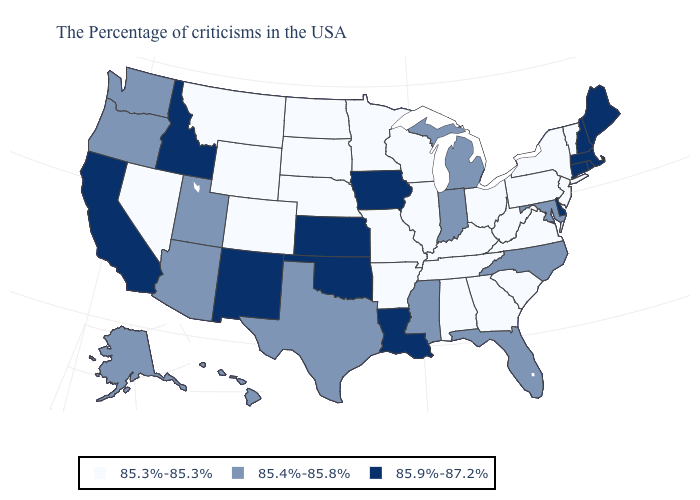What is the value of Montana?
Write a very short answer. 85.3%-85.3%. What is the value of Utah?
Give a very brief answer. 85.4%-85.8%. What is the lowest value in the USA?
Concise answer only. 85.3%-85.3%. Does Georgia have the same value as Colorado?
Give a very brief answer. Yes. Does Louisiana have the lowest value in the USA?
Keep it brief. No. What is the highest value in the West ?
Concise answer only. 85.9%-87.2%. What is the lowest value in the West?
Write a very short answer. 85.3%-85.3%. Among the states that border New Jersey , which have the lowest value?
Write a very short answer. New York, Pennsylvania. Which states have the lowest value in the USA?
Keep it brief. Vermont, New York, New Jersey, Pennsylvania, Virginia, South Carolina, West Virginia, Ohio, Georgia, Kentucky, Alabama, Tennessee, Wisconsin, Illinois, Missouri, Arkansas, Minnesota, Nebraska, South Dakota, North Dakota, Wyoming, Colorado, Montana, Nevada. Which states hav the highest value in the South?
Be succinct. Delaware, Louisiana, Oklahoma. What is the value of Iowa?
Concise answer only. 85.9%-87.2%. What is the highest value in the South ?
Be succinct. 85.9%-87.2%. Name the states that have a value in the range 85.3%-85.3%?
Answer briefly. Vermont, New York, New Jersey, Pennsylvania, Virginia, South Carolina, West Virginia, Ohio, Georgia, Kentucky, Alabama, Tennessee, Wisconsin, Illinois, Missouri, Arkansas, Minnesota, Nebraska, South Dakota, North Dakota, Wyoming, Colorado, Montana, Nevada. Does Texas have a lower value than Arkansas?
Answer briefly. No. Does Vermont have the lowest value in the Northeast?
Keep it brief. Yes. 